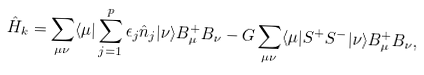<formula> <loc_0><loc_0><loc_500><loc_500>\hat { H } _ { k } = \sum _ { \mu \nu } \langle \mu | \sum _ { j = 1 } ^ { p } \epsilon _ { j } \hat { n } _ { j } | \nu \rangle B ^ { + } _ { \mu } B _ { \nu } - G \sum _ { \mu \nu } \langle \mu | S ^ { + } S ^ { - } | \nu \rangle B ^ { + } _ { \mu } B _ { \nu } ,</formula> 